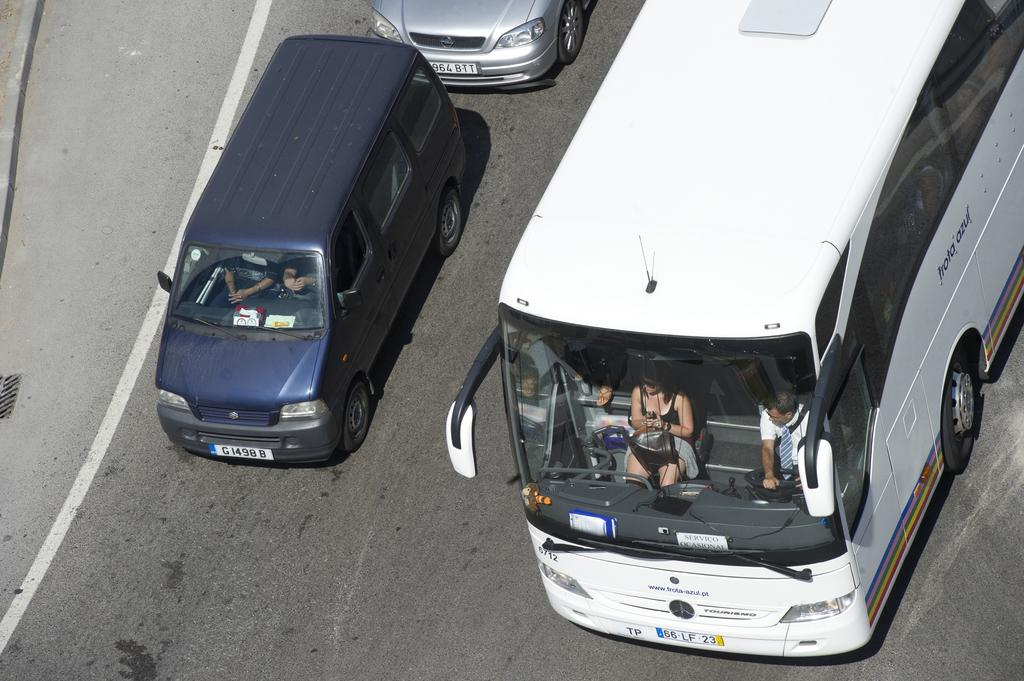What type of vehicle is on the road in the image? There is a bus on the road in the image. What other vehicles can be seen in the image? There are cars in the image. What is happening inside the bus? There are people sitting in the bus. Can you tell me how many chickens are on the bus in the image? There are no chickens present on the bus in the image. 